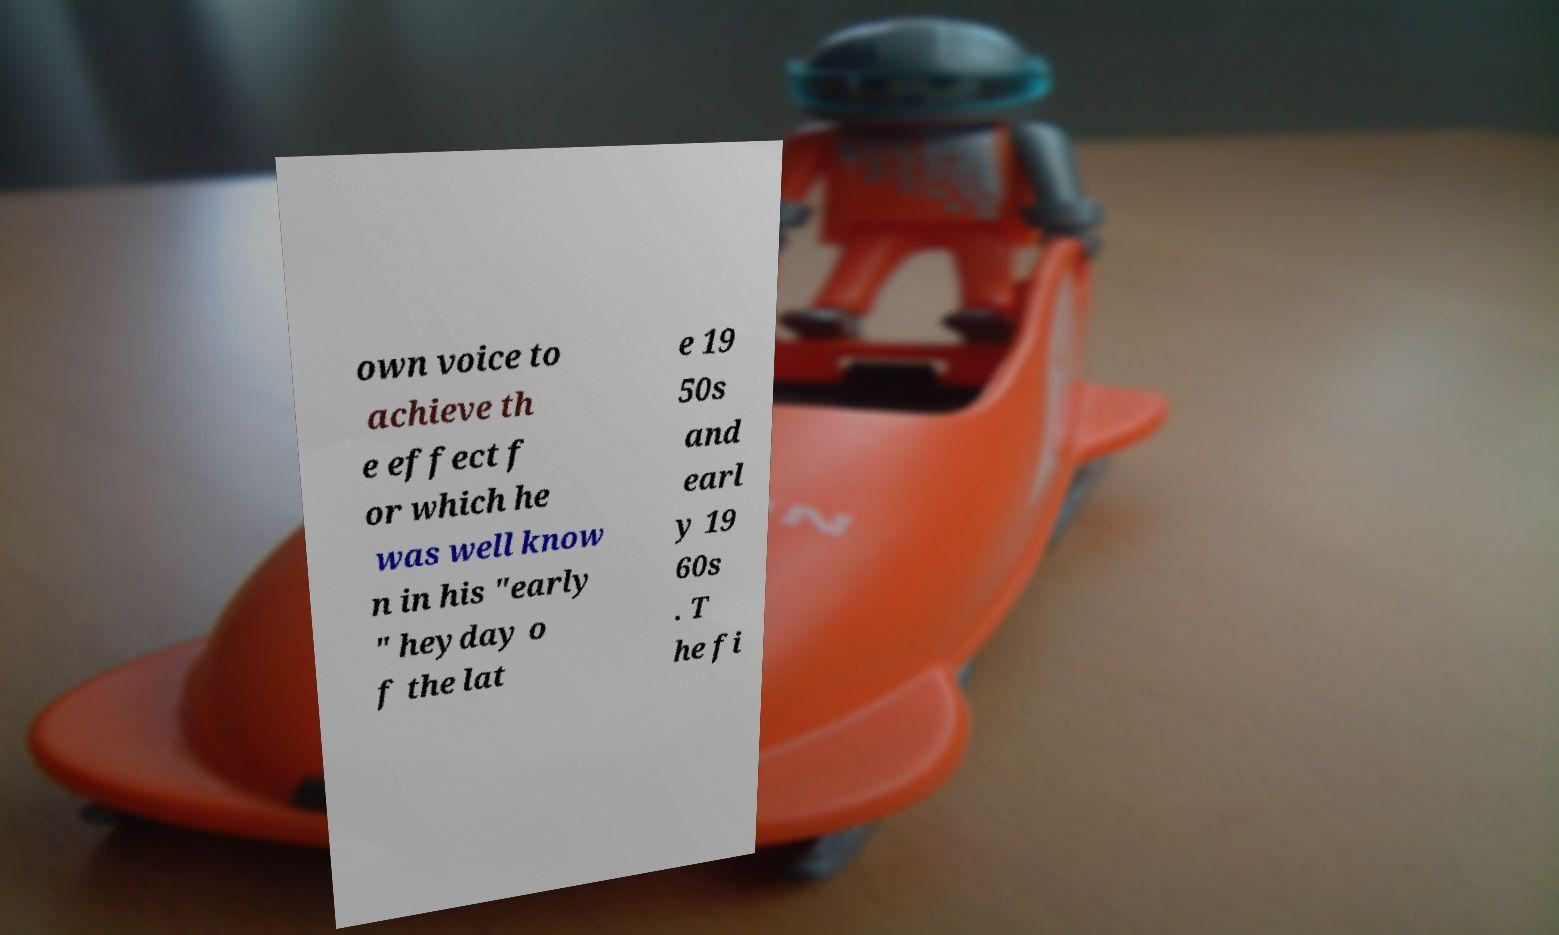Please read and relay the text visible in this image. What does it say? own voice to achieve th e effect f or which he was well know n in his "early " heyday o f the lat e 19 50s and earl y 19 60s . T he fi 